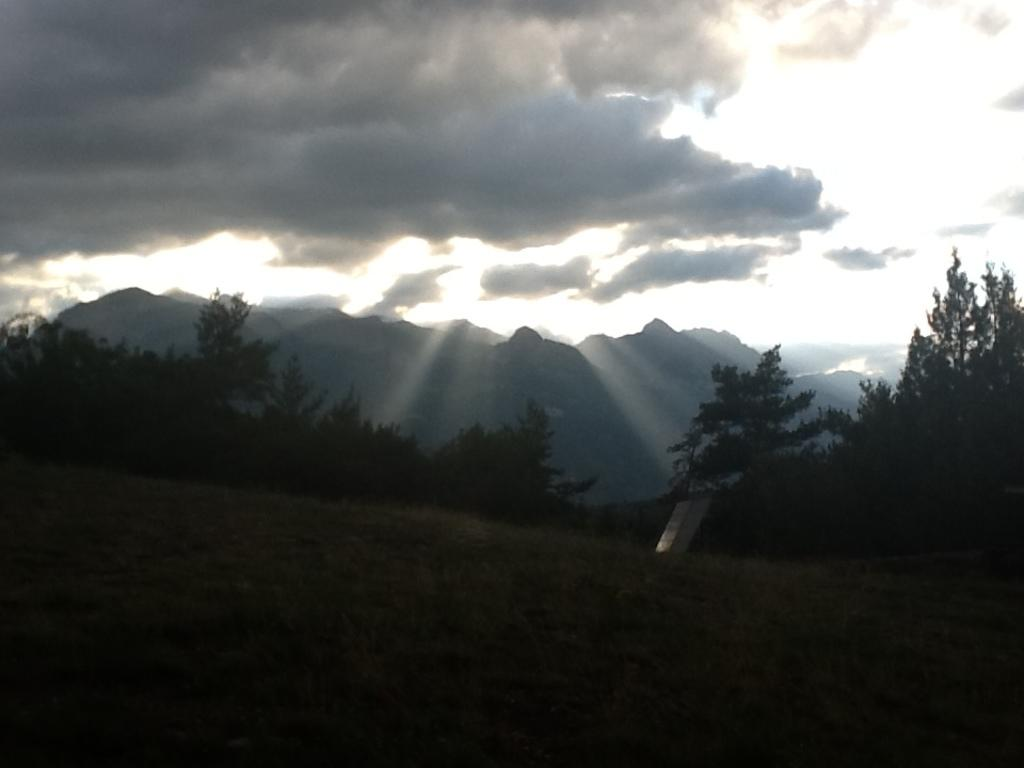What type of natural vegetation is visible in the image? There are trees in the image. What type of geographical feature can be seen in the image? There are mountains in the image. What part of the natural environment is visible in the image? The sky is visible in the image. How would you describe the lighting in the image? The image is a little bit dark. Where is the nest located in the image? There is no nest present in the image. What type of stove can be seen in the image? There is no stove present in the image. 